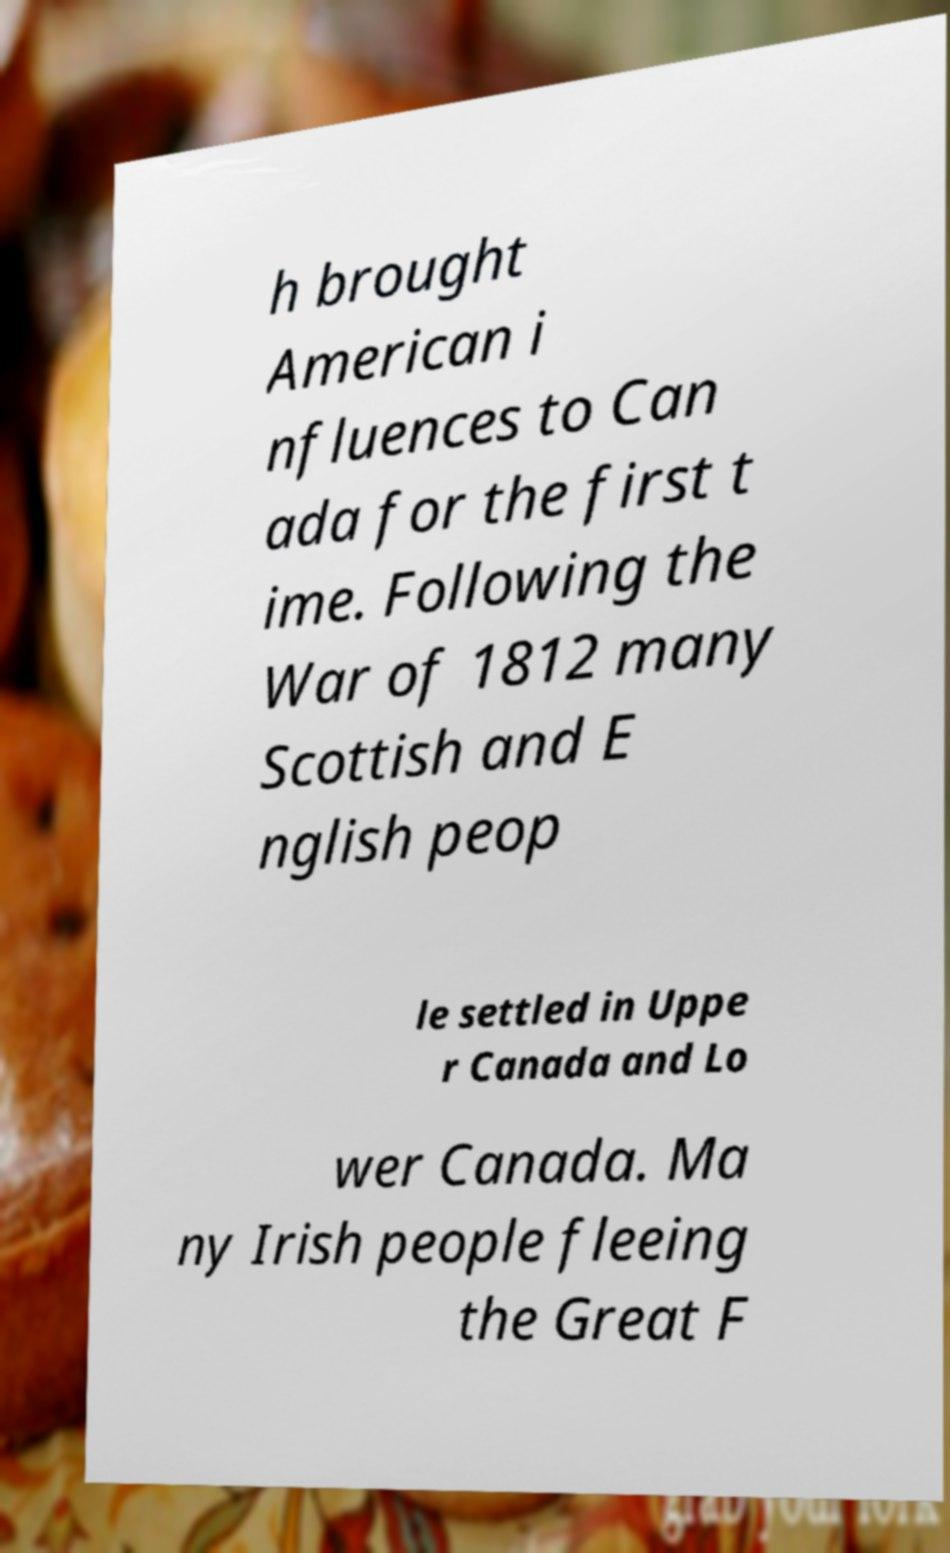Can you read and provide the text displayed in the image?This photo seems to have some interesting text. Can you extract and type it out for me? h brought American i nfluences to Can ada for the first t ime. Following the War of 1812 many Scottish and E nglish peop le settled in Uppe r Canada and Lo wer Canada. Ma ny Irish people fleeing the Great F 